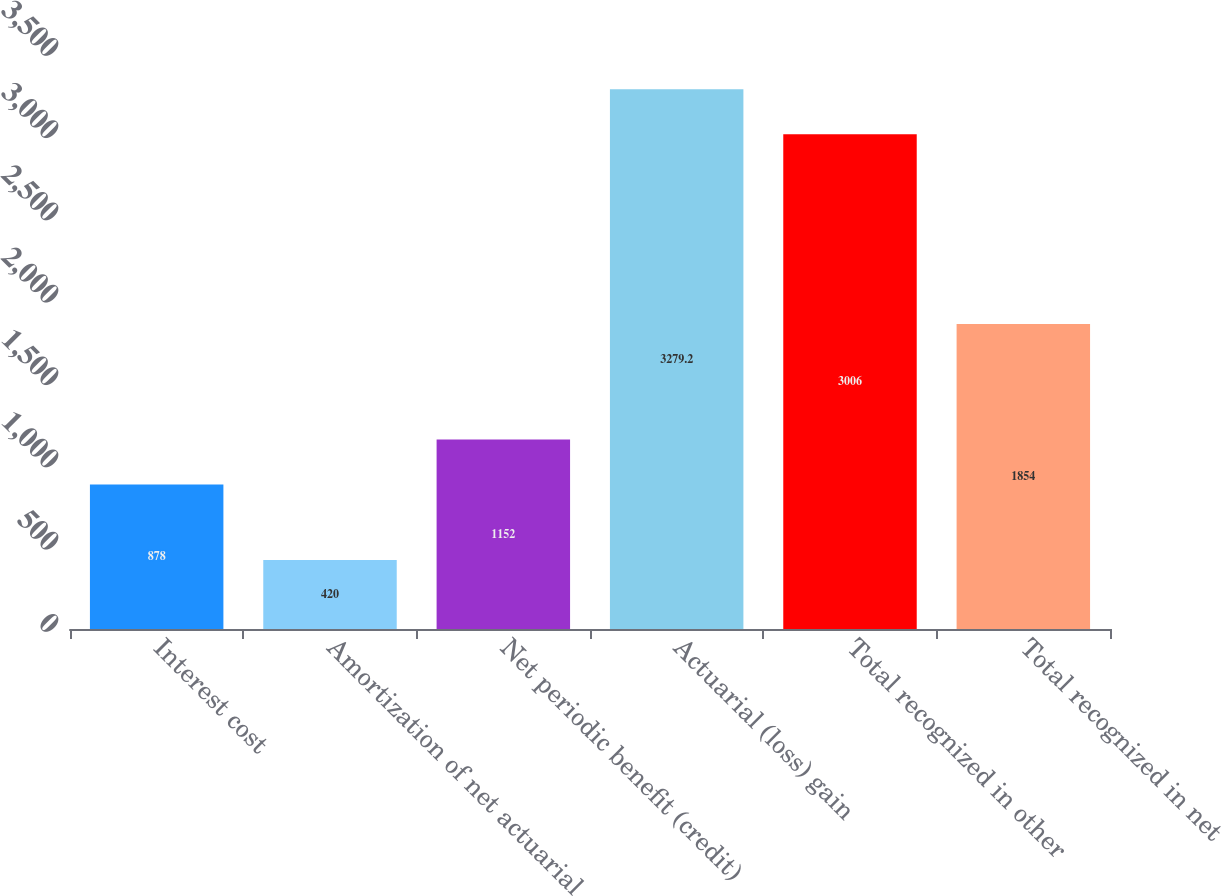<chart> <loc_0><loc_0><loc_500><loc_500><bar_chart><fcel>Interest cost<fcel>Amortization of net actuarial<fcel>Net periodic benefit (credit)<fcel>Actuarial (loss) gain<fcel>Total recognized in other<fcel>Total recognized in net<nl><fcel>878<fcel>420<fcel>1152<fcel>3279.2<fcel>3006<fcel>1854<nl></chart> 